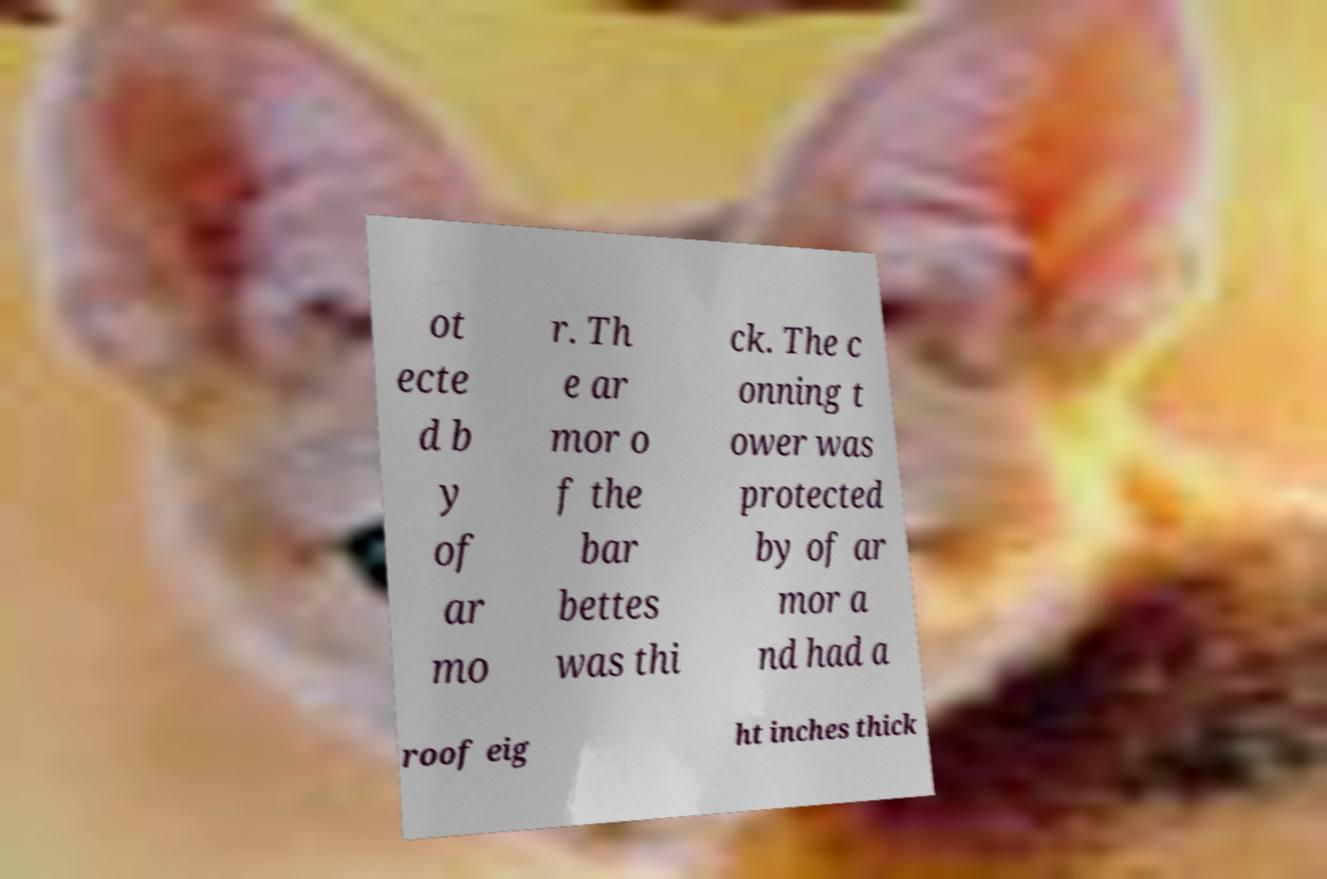Please read and relay the text visible in this image. What does it say? ot ecte d b y of ar mo r. Th e ar mor o f the bar bettes was thi ck. The c onning t ower was protected by of ar mor a nd had a roof eig ht inches thick 